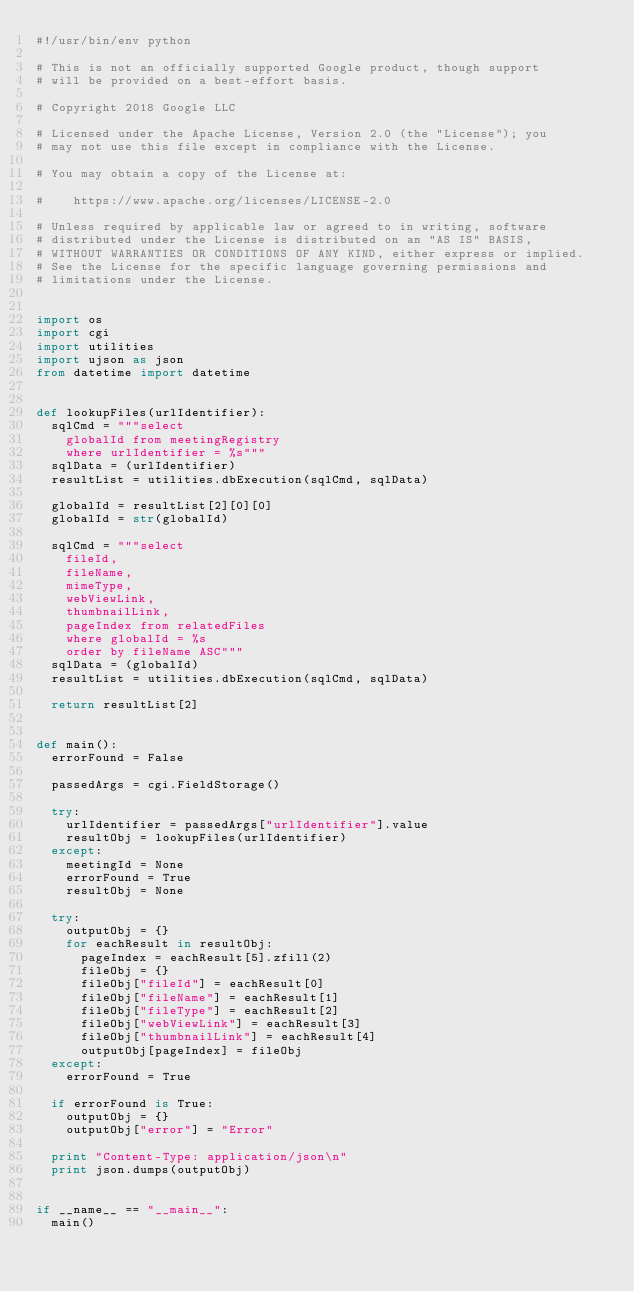<code> <loc_0><loc_0><loc_500><loc_500><_Python_>#!/usr/bin/env python

# This is not an officially supported Google product, though support
# will be provided on a best-effort basis.

# Copyright 2018 Google LLC

# Licensed under the Apache License, Version 2.0 (the "License"); you
# may not use this file except in compliance with the License.

# You may obtain a copy of the License at:

#    https://www.apache.org/licenses/LICENSE-2.0

# Unless required by applicable law or agreed to in writing, software
# distributed under the License is distributed on an "AS IS" BASIS,
# WITHOUT WARRANTIES OR CONDITIONS OF ANY KIND, either express or implied.
# See the License for the specific language governing permissions and
# limitations under the License.


import os
import cgi
import utilities
import ujson as json
from datetime import datetime


def lookupFiles(urlIdentifier):
	sqlCmd = """select
		globalId from meetingRegistry
		where urlIdentifier = %s"""
	sqlData = (urlIdentifier)
	resultList = utilities.dbExecution(sqlCmd, sqlData)

	globalId = resultList[2][0][0]
	globalId = str(globalId)

	sqlCmd = """select
		fileId,
		fileName,
		mimeType,
		webViewLink,
		thumbnailLink,
		pageIndex from relatedFiles
		where globalId = %s
		order by fileName ASC"""
	sqlData = (globalId)
	resultList = utilities.dbExecution(sqlCmd, sqlData)

	return resultList[2]


def main():
	errorFound = False

	passedArgs = cgi.FieldStorage()

	try:
		urlIdentifier = passedArgs["urlIdentifier"].value
		resultObj = lookupFiles(urlIdentifier)
	except:
		meetingId = None
		errorFound = True
		resultObj = None

	try:
		outputObj = {}
		for eachResult in resultObj:
			pageIndex = eachResult[5].zfill(2)
			fileObj = {}
			fileObj["fileId"] = eachResult[0]
			fileObj["fileName"] = eachResult[1]
			fileObj["fileType"] = eachResult[2]
			fileObj["webViewLink"] = eachResult[3]
			fileObj["thumbnailLink"] = eachResult[4]
			outputObj[pageIndex] = fileObj
	except:
		errorFound = True

	if errorFound is True:
		outputObj = {}
		outputObj["error"] = "Error"

	print "Content-Type: application/json\n"
	print json.dumps(outputObj)


if __name__ == "__main__":
	main()</code> 